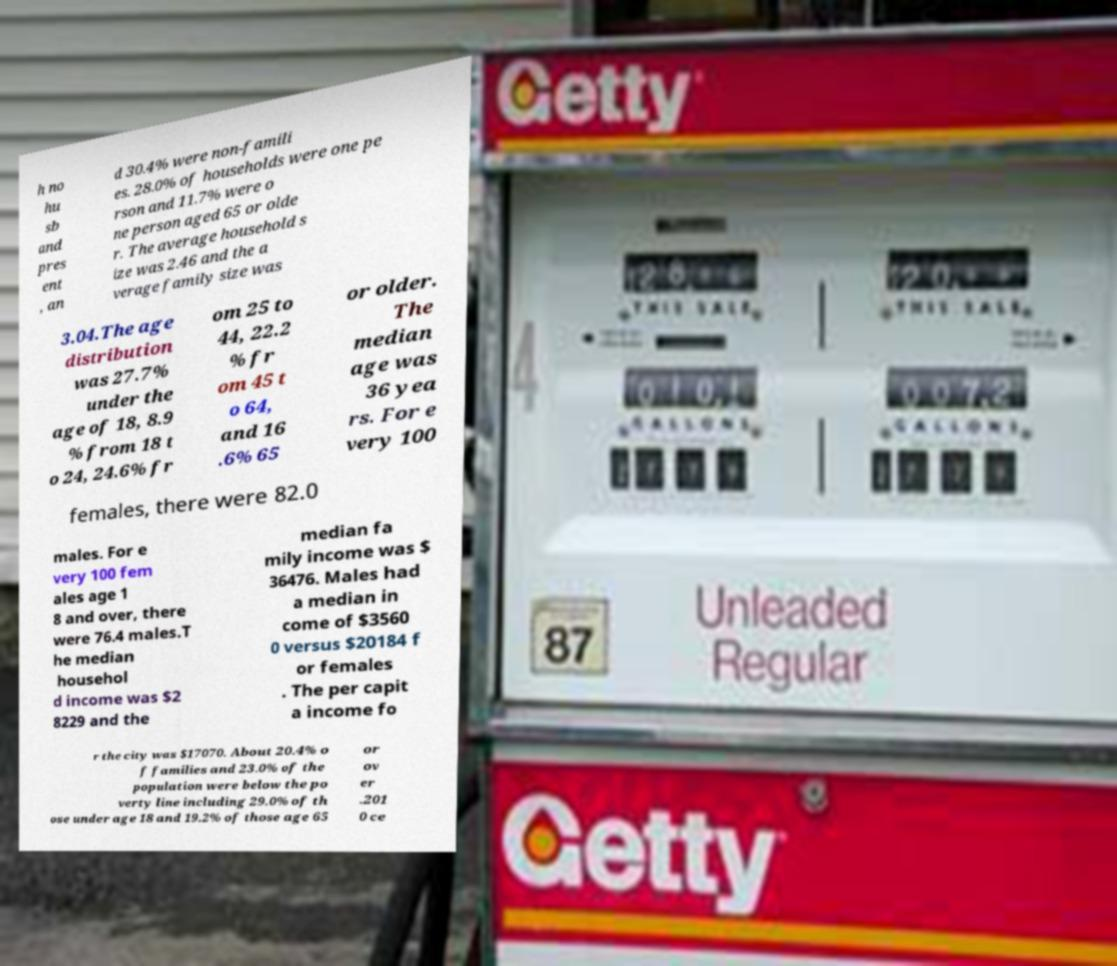What messages or text are displayed in this image? I need them in a readable, typed format. h no hu sb and pres ent , an d 30.4% were non-famili es. 28.0% of households were one pe rson and 11.7% were o ne person aged 65 or olde r. The average household s ize was 2.46 and the a verage family size was 3.04.The age distribution was 27.7% under the age of 18, 8.9 % from 18 t o 24, 24.6% fr om 25 to 44, 22.2 % fr om 45 t o 64, and 16 .6% 65 or older. The median age was 36 yea rs. For e very 100 females, there were 82.0 males. For e very 100 fem ales age 1 8 and over, there were 76.4 males.T he median househol d income was $2 8229 and the median fa mily income was $ 36476. Males had a median in come of $3560 0 versus $20184 f or females . The per capit a income fo r the city was $17070. About 20.4% o f families and 23.0% of the population were below the po verty line including 29.0% of th ose under age 18 and 19.2% of those age 65 or ov er .201 0 ce 